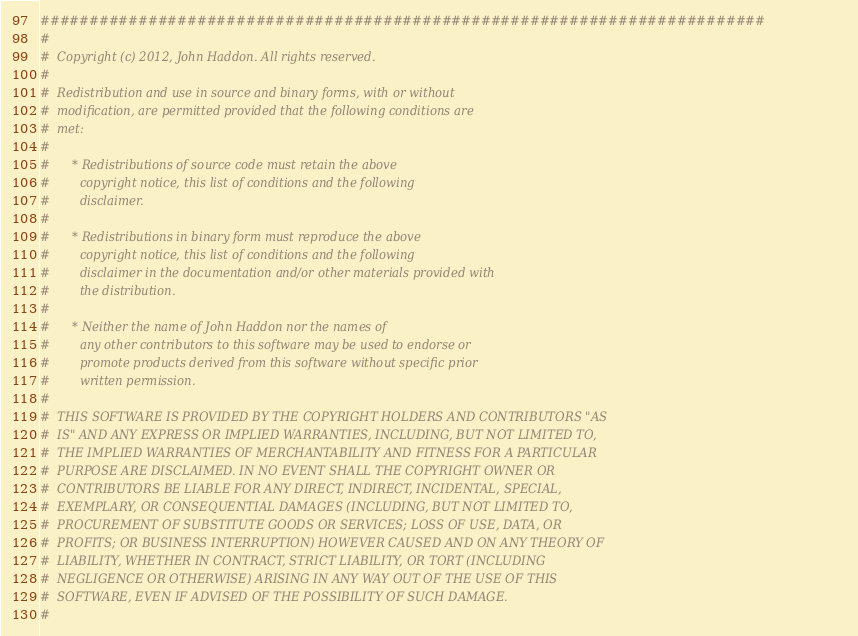<code> <loc_0><loc_0><loc_500><loc_500><_Python_>##########################################################################
#  
#  Copyright (c) 2012, John Haddon. All rights reserved.
#  
#  Redistribution and use in source and binary forms, with or without
#  modification, are permitted provided that the following conditions are
#  met:
#  
#      * Redistributions of source code must retain the above
#        copyright notice, this list of conditions and the following
#        disclaimer.
#  
#      * Redistributions in binary form must reproduce the above
#        copyright notice, this list of conditions and the following
#        disclaimer in the documentation and/or other materials provided with
#        the distribution.
#  
#      * Neither the name of John Haddon nor the names of
#        any other contributors to this software may be used to endorse or
#        promote products derived from this software without specific prior
#        written permission.
#  
#  THIS SOFTWARE IS PROVIDED BY THE COPYRIGHT HOLDERS AND CONTRIBUTORS "AS
#  IS" AND ANY EXPRESS OR IMPLIED WARRANTIES, INCLUDING, BUT NOT LIMITED TO,
#  THE IMPLIED WARRANTIES OF MERCHANTABILITY AND FITNESS FOR A PARTICULAR
#  PURPOSE ARE DISCLAIMED. IN NO EVENT SHALL THE COPYRIGHT OWNER OR
#  CONTRIBUTORS BE LIABLE FOR ANY DIRECT, INDIRECT, INCIDENTAL, SPECIAL,
#  EXEMPLARY, OR CONSEQUENTIAL DAMAGES (INCLUDING, BUT NOT LIMITED TO,
#  PROCUREMENT OF SUBSTITUTE GOODS OR SERVICES; LOSS OF USE, DATA, OR
#  PROFITS; OR BUSINESS INTERRUPTION) HOWEVER CAUSED AND ON ANY THEORY OF
#  LIABILITY, WHETHER IN CONTRACT, STRICT LIABILITY, OR TORT (INCLUDING
#  NEGLIGENCE OR OTHERWISE) ARISING IN ANY WAY OUT OF THE USE OF THIS
#  SOFTWARE, EVEN IF ADVISED OF THE POSSIBILITY OF SUCH DAMAGE.
#  </code> 